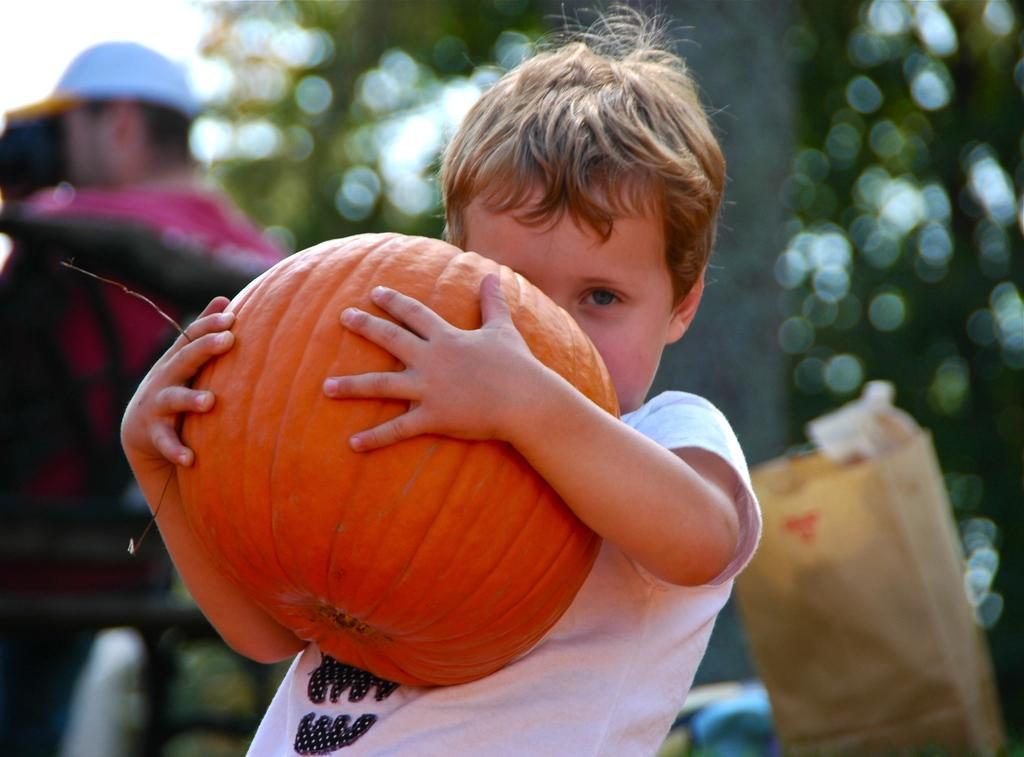Who is the main subject in the image? The main subject in the image is a boy. What is the boy wearing? The boy is wearing a white t-shirt. What is the boy holding in the image? The boy is holding a pumpkin. Can you describe the background of the image? The background of the image includes people, trees, and the sky. The background is slightly blurred. What type of note is the beggar holding in the image? There is no beggar or note present in the image. The boy is holding a pumpkin, and there are people and trees in the background. 